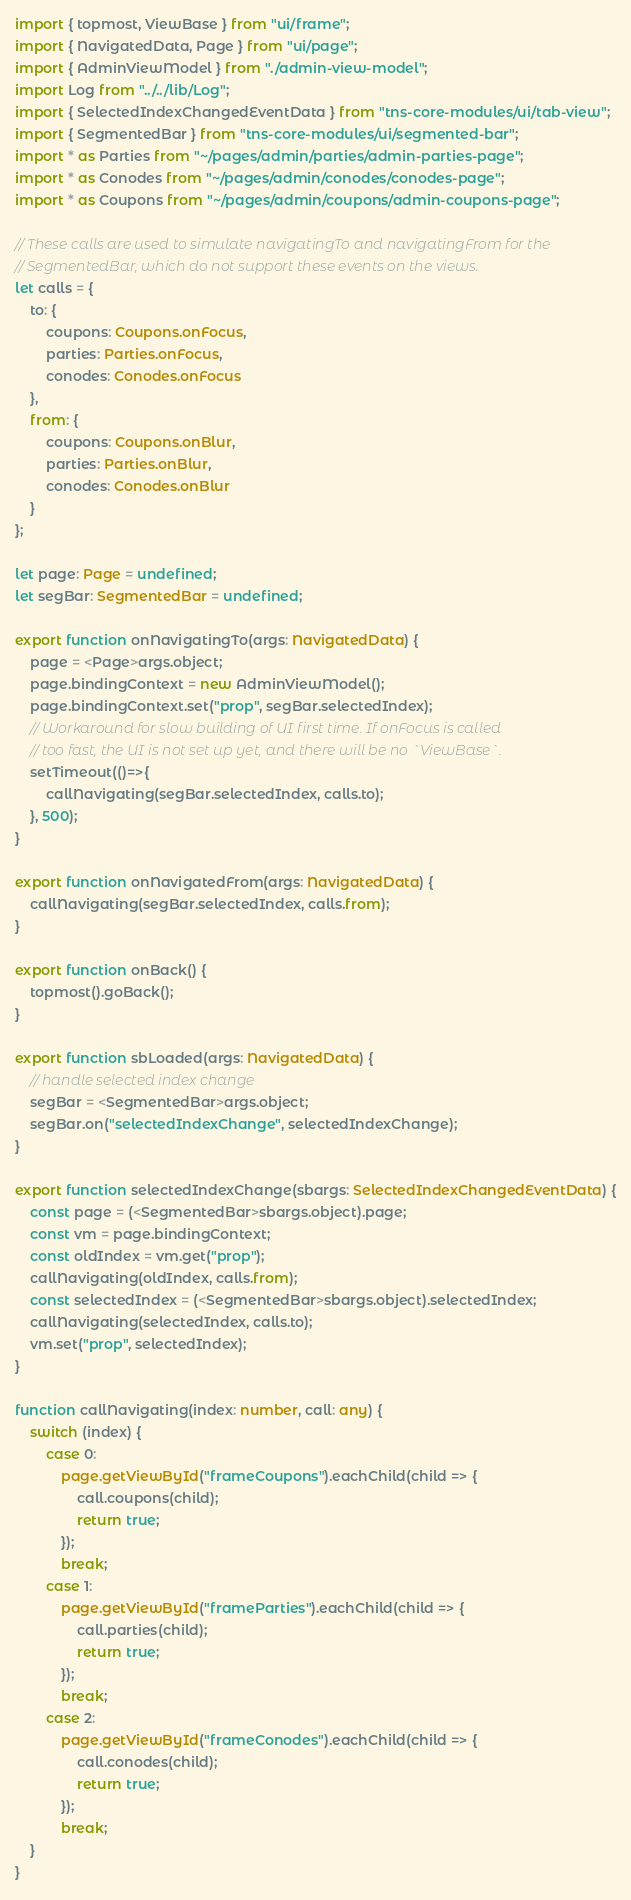<code> <loc_0><loc_0><loc_500><loc_500><_TypeScript_>import { topmost, ViewBase } from "ui/frame";
import { NavigatedData, Page } from "ui/page";
import { AdminViewModel } from "./admin-view-model";
import Log from "../../lib/Log";
import { SelectedIndexChangedEventData } from "tns-core-modules/ui/tab-view";
import { SegmentedBar } from "tns-core-modules/ui/segmented-bar";
import * as Parties from "~/pages/admin/parties/admin-parties-page";
import * as Conodes from "~/pages/admin/conodes/conodes-page";
import * as Coupons from "~/pages/admin/coupons/admin-coupons-page";

// These calls are used to simulate navigatingTo and navigatingFrom for the
// SegmentedBar, which do not support these events on the views.
let calls = {
    to: {
        coupons: Coupons.onFocus,
        parties: Parties.onFocus,
        conodes: Conodes.onFocus
    },
    from: {
        coupons: Coupons.onBlur,
        parties: Parties.onBlur,
        conodes: Conodes.onBlur
    }
};

let page: Page = undefined;
let segBar: SegmentedBar = undefined;

export function onNavigatingTo(args: NavigatedData) {
    page = <Page>args.object;
    page.bindingContext = new AdminViewModel();
    page.bindingContext.set("prop", segBar.selectedIndex);
    // Workaround for slow building of UI first time. If onFocus is called
    // too fast, the UI is not set up yet, and there will be no `ViewBase`.
    setTimeout(()=>{
        callNavigating(segBar.selectedIndex, calls.to);
    }, 500);
}

export function onNavigatedFrom(args: NavigatedData) {
    callNavigating(segBar.selectedIndex, calls.from);
}

export function onBack() {
    topmost().goBack();
}

export function sbLoaded(args: NavigatedData) {
    // handle selected index change
    segBar = <SegmentedBar>args.object;
    segBar.on("selectedIndexChange", selectedIndexChange);
}

export function selectedIndexChange(sbargs: SelectedIndexChangedEventData) {
    const page = (<SegmentedBar>sbargs.object).page;
    const vm = page.bindingContext;
    const oldIndex = vm.get("prop");
    callNavigating(oldIndex, calls.from);
    const selectedIndex = (<SegmentedBar>sbargs.object).selectedIndex;
    callNavigating(selectedIndex, calls.to);
    vm.set("prop", selectedIndex);
}

function callNavigating(index: number, call: any) {
    switch (index) {
        case 0:
            page.getViewById("frameCoupons").eachChild(child => {
                call.coupons(child);
                return true;
            });
            break;
        case 1:
            page.getViewById("frameParties").eachChild(child => {
                call.parties(child);
                return true;
            });
            break;
        case 2:
            page.getViewById("frameConodes").eachChild(child => {
                call.conodes(child);
                return true;
            });
            break;
    }
}</code> 